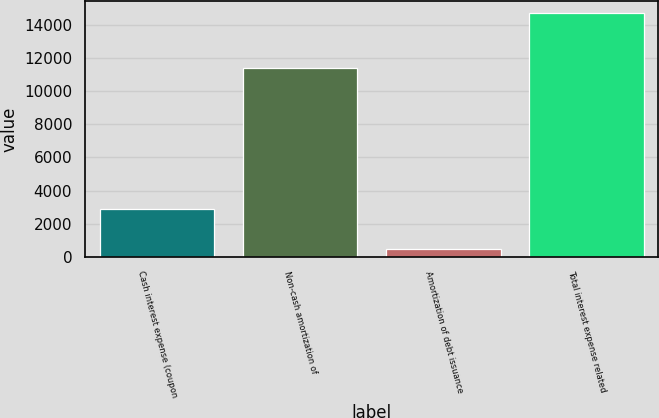Convert chart. <chart><loc_0><loc_0><loc_500><loc_500><bar_chart><fcel>Cash interest expense (coupon<fcel>Non-cash amortization of<fcel>Amortization of debt issuance<fcel>Total interest expense related<nl><fcel>2875<fcel>11387<fcel>466<fcel>14728<nl></chart> 